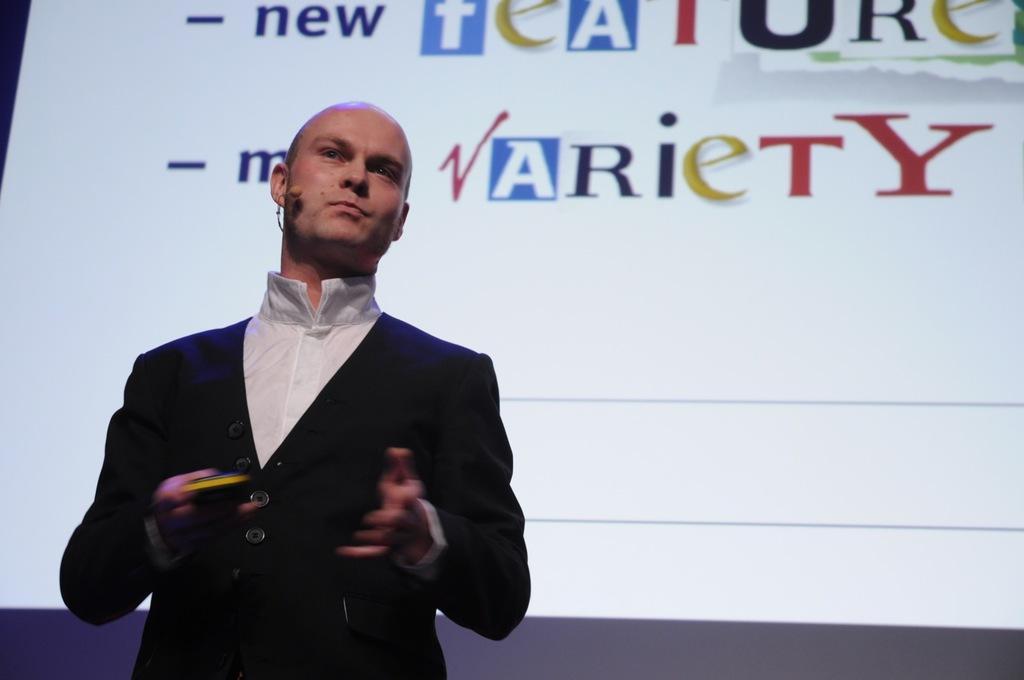Can you describe this image briefly? In this image in the front there is a man standing and in the background there is a screen with some text displaying on the screen. 